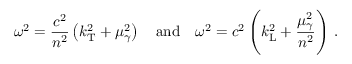<formula> <loc_0><loc_0><loc_500><loc_500>\omega ^ { 2 } = \frac { c ^ { 2 } } { n ^ { 2 } } \left ( k _ { T } ^ { 2 } + \mu _ { \gamma } ^ { 2 } \right ) \quad a n d \quad \omega ^ { 2 } = c ^ { 2 } \left ( k _ { L } ^ { 2 } + \frac { \mu _ { \gamma } ^ { 2 } } { n ^ { 2 } } \right ) \, .</formula> 